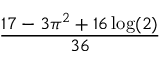Convert formula to latex. <formula><loc_0><loc_0><loc_500><loc_500>\frac { 1 7 - 3 \pi ^ { 2 } + 1 6 \log ( 2 ) } { 3 6 }</formula> 